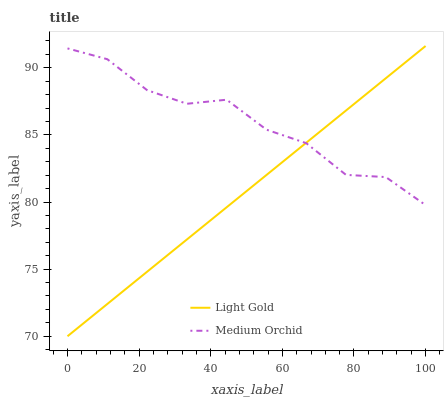Does Light Gold have the minimum area under the curve?
Answer yes or no. Yes. Does Medium Orchid have the maximum area under the curve?
Answer yes or no. Yes. Does Light Gold have the maximum area under the curve?
Answer yes or no. No. Is Light Gold the smoothest?
Answer yes or no. Yes. Is Medium Orchid the roughest?
Answer yes or no. Yes. Is Light Gold the roughest?
Answer yes or no. No. Does Light Gold have the highest value?
Answer yes or no. Yes. Does Medium Orchid intersect Light Gold?
Answer yes or no. Yes. Is Medium Orchid less than Light Gold?
Answer yes or no. No. Is Medium Orchid greater than Light Gold?
Answer yes or no. No. 